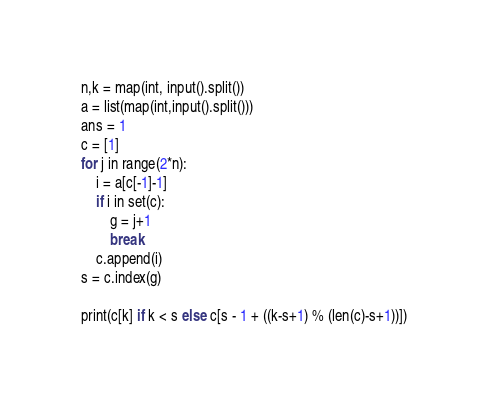Convert code to text. <code><loc_0><loc_0><loc_500><loc_500><_Python_>n,k = map(int, input().split())
a = list(map(int,input().split()))
ans = 1
c = [1]
for j in range(2*n):
    i = a[c[-1]-1]
    if i in set(c):
        g = j+1
        break
    c.append(i)
s = c.index(g)

print(c[k] if k < s else c[s - 1 + ((k-s+1) % (len(c)-s+1))])</code> 